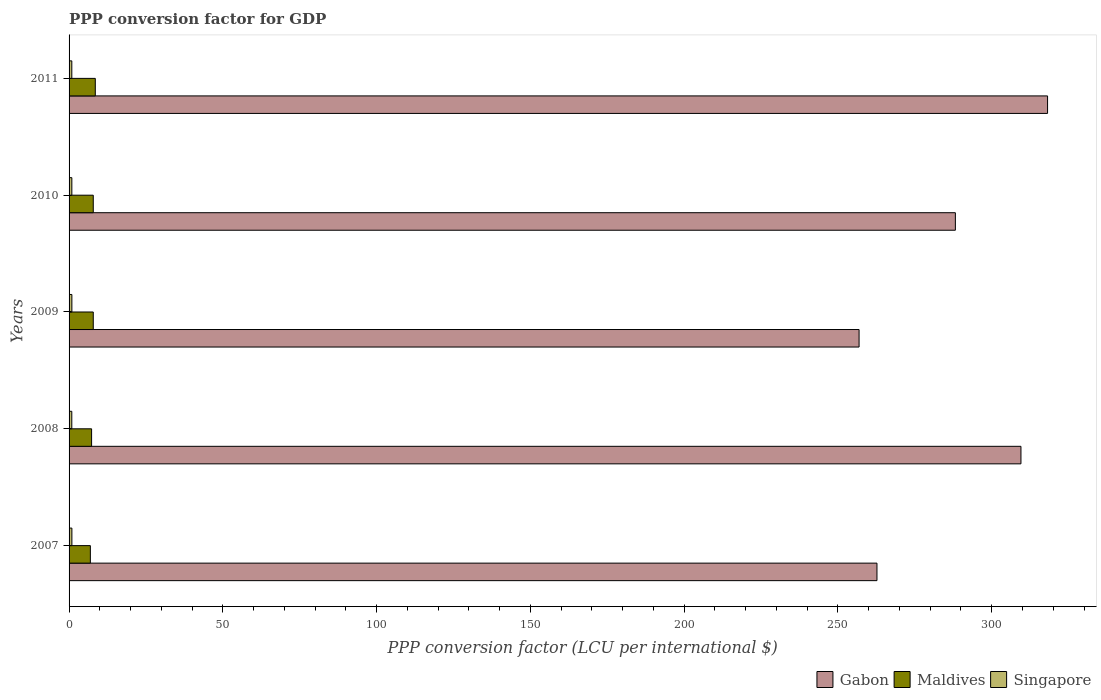How many different coloured bars are there?
Make the answer very short. 3. How many groups of bars are there?
Ensure brevity in your answer.  5. Are the number of bars per tick equal to the number of legend labels?
Offer a terse response. Yes. Are the number of bars on each tick of the Y-axis equal?
Your answer should be compact. Yes. How many bars are there on the 2nd tick from the top?
Keep it short and to the point. 3. How many bars are there on the 2nd tick from the bottom?
Your answer should be compact. 3. What is the PPP conversion factor for GDP in Gabon in 2008?
Your answer should be compact. 309.5. Across all years, what is the maximum PPP conversion factor for GDP in Gabon?
Provide a succinct answer. 318.16. Across all years, what is the minimum PPP conversion factor for GDP in Gabon?
Provide a succinct answer. 256.87. In which year was the PPP conversion factor for GDP in Maldives maximum?
Provide a short and direct response. 2011. What is the total PPP conversion factor for GDP in Gabon in the graph?
Your answer should be very brief. 1435.39. What is the difference between the PPP conversion factor for GDP in Maldives in 2009 and that in 2011?
Make the answer very short. -0.66. What is the difference between the PPP conversion factor for GDP in Gabon in 2010 and the PPP conversion factor for GDP in Maldives in 2007?
Keep it short and to the point. 281.26. What is the average PPP conversion factor for GDP in Gabon per year?
Your answer should be compact. 287.08. In the year 2007, what is the difference between the PPP conversion factor for GDP in Maldives and PPP conversion factor for GDP in Singapore?
Your response must be concise. 6. In how many years, is the PPP conversion factor for GDP in Gabon greater than 80 LCU?
Offer a very short reply. 5. What is the ratio of the PPP conversion factor for GDP in Maldives in 2009 to that in 2010?
Your answer should be very brief. 1. What is the difference between the highest and the second highest PPP conversion factor for GDP in Singapore?
Offer a very short reply. 0.01. What is the difference between the highest and the lowest PPP conversion factor for GDP in Gabon?
Make the answer very short. 61.29. Is the sum of the PPP conversion factor for GDP in Singapore in 2010 and 2011 greater than the maximum PPP conversion factor for GDP in Gabon across all years?
Give a very brief answer. No. What does the 1st bar from the top in 2007 represents?
Your response must be concise. Singapore. What does the 1st bar from the bottom in 2009 represents?
Make the answer very short. Gabon. How many bars are there?
Provide a succinct answer. 15. How many years are there in the graph?
Your response must be concise. 5. What is the difference between two consecutive major ticks on the X-axis?
Offer a terse response. 50. Are the values on the major ticks of X-axis written in scientific E-notation?
Offer a very short reply. No. How many legend labels are there?
Keep it short and to the point. 3. How are the legend labels stacked?
Make the answer very short. Horizontal. What is the title of the graph?
Offer a terse response. PPP conversion factor for GDP. Does "Romania" appear as one of the legend labels in the graph?
Ensure brevity in your answer.  No. What is the label or title of the X-axis?
Keep it short and to the point. PPP conversion factor (LCU per international $). What is the PPP conversion factor (LCU per international $) of Gabon in 2007?
Give a very brief answer. 262.69. What is the PPP conversion factor (LCU per international $) in Maldives in 2007?
Provide a succinct answer. 6.92. What is the PPP conversion factor (LCU per international $) in Singapore in 2007?
Your answer should be very brief. 0.92. What is the PPP conversion factor (LCU per international $) in Gabon in 2008?
Your answer should be compact. 309.5. What is the PPP conversion factor (LCU per international $) in Maldives in 2008?
Your response must be concise. 7.32. What is the PPP conversion factor (LCU per international $) of Singapore in 2008?
Offer a terse response. 0.89. What is the PPP conversion factor (LCU per international $) of Gabon in 2009?
Ensure brevity in your answer.  256.87. What is the PPP conversion factor (LCU per international $) of Maldives in 2009?
Offer a very short reply. 7.87. What is the PPP conversion factor (LCU per international $) of Singapore in 2009?
Ensure brevity in your answer.  0.91. What is the PPP conversion factor (LCU per international $) in Gabon in 2010?
Your response must be concise. 288.18. What is the PPP conversion factor (LCU per international $) of Maldives in 2010?
Your response must be concise. 7.87. What is the PPP conversion factor (LCU per international $) in Singapore in 2010?
Make the answer very short. 0.9. What is the PPP conversion factor (LCU per international $) of Gabon in 2011?
Your response must be concise. 318.16. What is the PPP conversion factor (LCU per international $) in Maldives in 2011?
Make the answer very short. 8.53. What is the PPP conversion factor (LCU per international $) in Singapore in 2011?
Give a very brief answer. 0.89. Across all years, what is the maximum PPP conversion factor (LCU per international $) of Gabon?
Give a very brief answer. 318.16. Across all years, what is the maximum PPP conversion factor (LCU per international $) of Maldives?
Give a very brief answer. 8.53. Across all years, what is the maximum PPP conversion factor (LCU per international $) in Singapore?
Make the answer very short. 0.92. Across all years, what is the minimum PPP conversion factor (LCU per international $) in Gabon?
Your answer should be compact. 256.87. Across all years, what is the minimum PPP conversion factor (LCU per international $) in Maldives?
Provide a succinct answer. 6.92. Across all years, what is the minimum PPP conversion factor (LCU per international $) of Singapore?
Offer a terse response. 0.89. What is the total PPP conversion factor (LCU per international $) in Gabon in the graph?
Provide a succinct answer. 1435.39. What is the total PPP conversion factor (LCU per international $) of Maldives in the graph?
Keep it short and to the point. 38.5. What is the total PPP conversion factor (LCU per international $) of Singapore in the graph?
Offer a terse response. 4.51. What is the difference between the PPP conversion factor (LCU per international $) in Gabon in 2007 and that in 2008?
Offer a terse response. -46.82. What is the difference between the PPP conversion factor (LCU per international $) of Maldives in 2007 and that in 2008?
Provide a short and direct response. -0.4. What is the difference between the PPP conversion factor (LCU per international $) of Singapore in 2007 and that in 2008?
Your answer should be very brief. 0.03. What is the difference between the PPP conversion factor (LCU per international $) of Gabon in 2007 and that in 2009?
Your answer should be very brief. 5.82. What is the difference between the PPP conversion factor (LCU per international $) in Maldives in 2007 and that in 2009?
Offer a very short reply. -0.94. What is the difference between the PPP conversion factor (LCU per international $) of Singapore in 2007 and that in 2009?
Keep it short and to the point. 0.01. What is the difference between the PPP conversion factor (LCU per international $) of Gabon in 2007 and that in 2010?
Your answer should be compact. -25.49. What is the difference between the PPP conversion factor (LCU per international $) of Maldives in 2007 and that in 2010?
Your answer should be very brief. -0.94. What is the difference between the PPP conversion factor (LCU per international $) in Singapore in 2007 and that in 2010?
Provide a succinct answer. 0.02. What is the difference between the PPP conversion factor (LCU per international $) of Gabon in 2007 and that in 2011?
Provide a succinct answer. -55.47. What is the difference between the PPP conversion factor (LCU per international $) of Maldives in 2007 and that in 2011?
Offer a terse response. -1.6. What is the difference between the PPP conversion factor (LCU per international $) in Singapore in 2007 and that in 2011?
Offer a very short reply. 0.03. What is the difference between the PPP conversion factor (LCU per international $) of Gabon in 2008 and that in 2009?
Offer a very short reply. 52.63. What is the difference between the PPP conversion factor (LCU per international $) in Maldives in 2008 and that in 2009?
Offer a very short reply. -0.55. What is the difference between the PPP conversion factor (LCU per international $) in Singapore in 2008 and that in 2009?
Your answer should be very brief. -0.02. What is the difference between the PPP conversion factor (LCU per international $) of Gabon in 2008 and that in 2010?
Keep it short and to the point. 21.32. What is the difference between the PPP conversion factor (LCU per international $) of Maldives in 2008 and that in 2010?
Offer a terse response. -0.54. What is the difference between the PPP conversion factor (LCU per international $) of Singapore in 2008 and that in 2010?
Provide a succinct answer. -0.01. What is the difference between the PPP conversion factor (LCU per international $) in Gabon in 2008 and that in 2011?
Provide a short and direct response. -8.65. What is the difference between the PPP conversion factor (LCU per international $) of Maldives in 2008 and that in 2011?
Offer a terse response. -1.21. What is the difference between the PPP conversion factor (LCU per international $) of Singapore in 2008 and that in 2011?
Provide a short and direct response. -0. What is the difference between the PPP conversion factor (LCU per international $) in Gabon in 2009 and that in 2010?
Offer a very short reply. -31.31. What is the difference between the PPP conversion factor (LCU per international $) in Maldives in 2009 and that in 2010?
Your answer should be compact. 0. What is the difference between the PPP conversion factor (LCU per international $) of Singapore in 2009 and that in 2010?
Ensure brevity in your answer.  0.01. What is the difference between the PPP conversion factor (LCU per international $) of Gabon in 2009 and that in 2011?
Keep it short and to the point. -61.29. What is the difference between the PPP conversion factor (LCU per international $) of Maldives in 2009 and that in 2011?
Keep it short and to the point. -0.66. What is the difference between the PPP conversion factor (LCU per international $) in Singapore in 2009 and that in 2011?
Provide a succinct answer. 0.02. What is the difference between the PPP conversion factor (LCU per international $) of Gabon in 2010 and that in 2011?
Make the answer very short. -29.98. What is the difference between the PPP conversion factor (LCU per international $) of Maldives in 2010 and that in 2011?
Provide a succinct answer. -0.66. What is the difference between the PPP conversion factor (LCU per international $) of Singapore in 2010 and that in 2011?
Provide a short and direct response. 0.01. What is the difference between the PPP conversion factor (LCU per international $) in Gabon in 2007 and the PPP conversion factor (LCU per international $) in Maldives in 2008?
Your response must be concise. 255.36. What is the difference between the PPP conversion factor (LCU per international $) in Gabon in 2007 and the PPP conversion factor (LCU per international $) in Singapore in 2008?
Your answer should be very brief. 261.8. What is the difference between the PPP conversion factor (LCU per international $) of Maldives in 2007 and the PPP conversion factor (LCU per international $) of Singapore in 2008?
Offer a very short reply. 6.04. What is the difference between the PPP conversion factor (LCU per international $) in Gabon in 2007 and the PPP conversion factor (LCU per international $) in Maldives in 2009?
Give a very brief answer. 254.82. What is the difference between the PPP conversion factor (LCU per international $) in Gabon in 2007 and the PPP conversion factor (LCU per international $) in Singapore in 2009?
Offer a terse response. 261.78. What is the difference between the PPP conversion factor (LCU per international $) of Maldives in 2007 and the PPP conversion factor (LCU per international $) of Singapore in 2009?
Offer a terse response. 6.01. What is the difference between the PPP conversion factor (LCU per international $) of Gabon in 2007 and the PPP conversion factor (LCU per international $) of Maldives in 2010?
Offer a very short reply. 254.82. What is the difference between the PPP conversion factor (LCU per international $) of Gabon in 2007 and the PPP conversion factor (LCU per international $) of Singapore in 2010?
Keep it short and to the point. 261.79. What is the difference between the PPP conversion factor (LCU per international $) in Maldives in 2007 and the PPP conversion factor (LCU per international $) in Singapore in 2010?
Provide a succinct answer. 6.02. What is the difference between the PPP conversion factor (LCU per international $) in Gabon in 2007 and the PPP conversion factor (LCU per international $) in Maldives in 2011?
Your answer should be very brief. 254.16. What is the difference between the PPP conversion factor (LCU per international $) in Gabon in 2007 and the PPP conversion factor (LCU per international $) in Singapore in 2011?
Provide a short and direct response. 261.79. What is the difference between the PPP conversion factor (LCU per international $) of Maldives in 2007 and the PPP conversion factor (LCU per international $) of Singapore in 2011?
Your response must be concise. 6.03. What is the difference between the PPP conversion factor (LCU per international $) in Gabon in 2008 and the PPP conversion factor (LCU per international $) in Maldives in 2009?
Your answer should be compact. 301.64. What is the difference between the PPP conversion factor (LCU per international $) in Gabon in 2008 and the PPP conversion factor (LCU per international $) in Singapore in 2009?
Ensure brevity in your answer.  308.59. What is the difference between the PPP conversion factor (LCU per international $) of Maldives in 2008 and the PPP conversion factor (LCU per international $) of Singapore in 2009?
Make the answer very short. 6.41. What is the difference between the PPP conversion factor (LCU per international $) in Gabon in 2008 and the PPP conversion factor (LCU per international $) in Maldives in 2010?
Provide a succinct answer. 301.64. What is the difference between the PPP conversion factor (LCU per international $) of Gabon in 2008 and the PPP conversion factor (LCU per international $) of Singapore in 2010?
Ensure brevity in your answer.  308.6. What is the difference between the PPP conversion factor (LCU per international $) in Maldives in 2008 and the PPP conversion factor (LCU per international $) in Singapore in 2010?
Your answer should be very brief. 6.42. What is the difference between the PPP conversion factor (LCU per international $) in Gabon in 2008 and the PPP conversion factor (LCU per international $) in Maldives in 2011?
Keep it short and to the point. 300.98. What is the difference between the PPP conversion factor (LCU per international $) in Gabon in 2008 and the PPP conversion factor (LCU per international $) in Singapore in 2011?
Offer a terse response. 308.61. What is the difference between the PPP conversion factor (LCU per international $) of Maldives in 2008 and the PPP conversion factor (LCU per international $) of Singapore in 2011?
Offer a very short reply. 6.43. What is the difference between the PPP conversion factor (LCU per international $) of Gabon in 2009 and the PPP conversion factor (LCU per international $) of Maldives in 2010?
Keep it short and to the point. 249. What is the difference between the PPP conversion factor (LCU per international $) of Gabon in 2009 and the PPP conversion factor (LCU per international $) of Singapore in 2010?
Offer a very short reply. 255.97. What is the difference between the PPP conversion factor (LCU per international $) in Maldives in 2009 and the PPP conversion factor (LCU per international $) in Singapore in 2010?
Provide a short and direct response. 6.97. What is the difference between the PPP conversion factor (LCU per international $) in Gabon in 2009 and the PPP conversion factor (LCU per international $) in Maldives in 2011?
Your answer should be very brief. 248.34. What is the difference between the PPP conversion factor (LCU per international $) of Gabon in 2009 and the PPP conversion factor (LCU per international $) of Singapore in 2011?
Ensure brevity in your answer.  255.98. What is the difference between the PPP conversion factor (LCU per international $) in Maldives in 2009 and the PPP conversion factor (LCU per international $) in Singapore in 2011?
Your response must be concise. 6.98. What is the difference between the PPP conversion factor (LCU per international $) of Gabon in 2010 and the PPP conversion factor (LCU per international $) of Maldives in 2011?
Keep it short and to the point. 279.65. What is the difference between the PPP conversion factor (LCU per international $) in Gabon in 2010 and the PPP conversion factor (LCU per international $) in Singapore in 2011?
Your answer should be compact. 287.29. What is the difference between the PPP conversion factor (LCU per international $) in Maldives in 2010 and the PPP conversion factor (LCU per international $) in Singapore in 2011?
Your answer should be compact. 6.97. What is the average PPP conversion factor (LCU per international $) in Gabon per year?
Your answer should be very brief. 287.08. What is the average PPP conversion factor (LCU per international $) in Maldives per year?
Your answer should be compact. 7.7. What is the average PPP conversion factor (LCU per international $) in Singapore per year?
Provide a succinct answer. 0.9. In the year 2007, what is the difference between the PPP conversion factor (LCU per international $) in Gabon and PPP conversion factor (LCU per international $) in Maldives?
Make the answer very short. 255.76. In the year 2007, what is the difference between the PPP conversion factor (LCU per international $) in Gabon and PPP conversion factor (LCU per international $) in Singapore?
Provide a short and direct response. 261.77. In the year 2007, what is the difference between the PPP conversion factor (LCU per international $) of Maldives and PPP conversion factor (LCU per international $) of Singapore?
Your answer should be very brief. 6. In the year 2008, what is the difference between the PPP conversion factor (LCU per international $) in Gabon and PPP conversion factor (LCU per international $) in Maldives?
Keep it short and to the point. 302.18. In the year 2008, what is the difference between the PPP conversion factor (LCU per international $) in Gabon and PPP conversion factor (LCU per international $) in Singapore?
Provide a succinct answer. 308.62. In the year 2008, what is the difference between the PPP conversion factor (LCU per international $) in Maldives and PPP conversion factor (LCU per international $) in Singapore?
Offer a very short reply. 6.43. In the year 2009, what is the difference between the PPP conversion factor (LCU per international $) in Gabon and PPP conversion factor (LCU per international $) in Maldives?
Offer a very short reply. 249. In the year 2009, what is the difference between the PPP conversion factor (LCU per international $) of Gabon and PPP conversion factor (LCU per international $) of Singapore?
Give a very brief answer. 255.96. In the year 2009, what is the difference between the PPP conversion factor (LCU per international $) of Maldives and PPP conversion factor (LCU per international $) of Singapore?
Your response must be concise. 6.96. In the year 2010, what is the difference between the PPP conversion factor (LCU per international $) of Gabon and PPP conversion factor (LCU per international $) of Maldives?
Provide a succinct answer. 280.31. In the year 2010, what is the difference between the PPP conversion factor (LCU per international $) in Gabon and PPP conversion factor (LCU per international $) in Singapore?
Provide a succinct answer. 287.28. In the year 2010, what is the difference between the PPP conversion factor (LCU per international $) of Maldives and PPP conversion factor (LCU per international $) of Singapore?
Provide a succinct answer. 6.97. In the year 2011, what is the difference between the PPP conversion factor (LCU per international $) of Gabon and PPP conversion factor (LCU per international $) of Maldives?
Make the answer very short. 309.63. In the year 2011, what is the difference between the PPP conversion factor (LCU per international $) of Gabon and PPP conversion factor (LCU per international $) of Singapore?
Make the answer very short. 317.26. In the year 2011, what is the difference between the PPP conversion factor (LCU per international $) in Maldives and PPP conversion factor (LCU per international $) in Singapore?
Offer a very short reply. 7.64. What is the ratio of the PPP conversion factor (LCU per international $) of Gabon in 2007 to that in 2008?
Your answer should be very brief. 0.85. What is the ratio of the PPP conversion factor (LCU per international $) in Maldives in 2007 to that in 2008?
Offer a terse response. 0.95. What is the ratio of the PPP conversion factor (LCU per international $) of Singapore in 2007 to that in 2008?
Provide a succinct answer. 1.04. What is the ratio of the PPP conversion factor (LCU per international $) in Gabon in 2007 to that in 2009?
Offer a terse response. 1.02. What is the ratio of the PPP conversion factor (LCU per international $) in Maldives in 2007 to that in 2009?
Offer a very short reply. 0.88. What is the ratio of the PPP conversion factor (LCU per international $) of Singapore in 2007 to that in 2009?
Make the answer very short. 1.01. What is the ratio of the PPP conversion factor (LCU per international $) in Gabon in 2007 to that in 2010?
Your answer should be very brief. 0.91. What is the ratio of the PPP conversion factor (LCU per international $) in Maldives in 2007 to that in 2010?
Make the answer very short. 0.88. What is the ratio of the PPP conversion factor (LCU per international $) in Singapore in 2007 to that in 2010?
Your response must be concise. 1.02. What is the ratio of the PPP conversion factor (LCU per international $) of Gabon in 2007 to that in 2011?
Your answer should be compact. 0.83. What is the ratio of the PPP conversion factor (LCU per international $) of Maldives in 2007 to that in 2011?
Offer a terse response. 0.81. What is the ratio of the PPP conversion factor (LCU per international $) of Singapore in 2007 to that in 2011?
Provide a short and direct response. 1.03. What is the ratio of the PPP conversion factor (LCU per international $) in Gabon in 2008 to that in 2009?
Your response must be concise. 1.2. What is the ratio of the PPP conversion factor (LCU per international $) in Maldives in 2008 to that in 2009?
Provide a short and direct response. 0.93. What is the ratio of the PPP conversion factor (LCU per international $) in Singapore in 2008 to that in 2009?
Your answer should be very brief. 0.97. What is the ratio of the PPP conversion factor (LCU per international $) in Gabon in 2008 to that in 2010?
Offer a terse response. 1.07. What is the ratio of the PPP conversion factor (LCU per international $) in Maldives in 2008 to that in 2010?
Make the answer very short. 0.93. What is the ratio of the PPP conversion factor (LCU per international $) of Singapore in 2008 to that in 2010?
Keep it short and to the point. 0.99. What is the ratio of the PPP conversion factor (LCU per international $) of Gabon in 2008 to that in 2011?
Provide a succinct answer. 0.97. What is the ratio of the PPP conversion factor (LCU per international $) of Maldives in 2008 to that in 2011?
Keep it short and to the point. 0.86. What is the ratio of the PPP conversion factor (LCU per international $) in Singapore in 2008 to that in 2011?
Your answer should be very brief. 0.99. What is the ratio of the PPP conversion factor (LCU per international $) in Gabon in 2009 to that in 2010?
Your answer should be very brief. 0.89. What is the ratio of the PPP conversion factor (LCU per international $) of Maldives in 2009 to that in 2010?
Make the answer very short. 1. What is the ratio of the PPP conversion factor (LCU per international $) in Singapore in 2009 to that in 2010?
Give a very brief answer. 1.01. What is the ratio of the PPP conversion factor (LCU per international $) in Gabon in 2009 to that in 2011?
Give a very brief answer. 0.81. What is the ratio of the PPP conversion factor (LCU per international $) in Maldives in 2009 to that in 2011?
Offer a terse response. 0.92. What is the ratio of the PPP conversion factor (LCU per international $) in Singapore in 2009 to that in 2011?
Provide a succinct answer. 1.02. What is the ratio of the PPP conversion factor (LCU per international $) of Gabon in 2010 to that in 2011?
Provide a short and direct response. 0.91. What is the ratio of the PPP conversion factor (LCU per international $) in Maldives in 2010 to that in 2011?
Your response must be concise. 0.92. What is the ratio of the PPP conversion factor (LCU per international $) of Singapore in 2010 to that in 2011?
Ensure brevity in your answer.  1.01. What is the difference between the highest and the second highest PPP conversion factor (LCU per international $) of Gabon?
Keep it short and to the point. 8.65. What is the difference between the highest and the second highest PPP conversion factor (LCU per international $) of Maldives?
Your response must be concise. 0.66. What is the difference between the highest and the second highest PPP conversion factor (LCU per international $) of Singapore?
Provide a succinct answer. 0.01. What is the difference between the highest and the lowest PPP conversion factor (LCU per international $) of Gabon?
Keep it short and to the point. 61.29. What is the difference between the highest and the lowest PPP conversion factor (LCU per international $) in Maldives?
Make the answer very short. 1.6. What is the difference between the highest and the lowest PPP conversion factor (LCU per international $) of Singapore?
Your answer should be very brief. 0.03. 